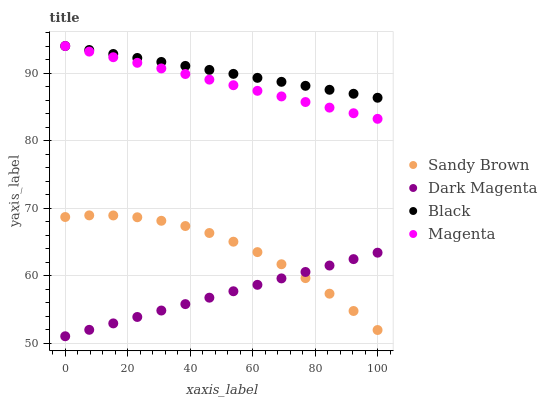Does Dark Magenta have the minimum area under the curve?
Answer yes or no. Yes. Does Black have the maximum area under the curve?
Answer yes or no. Yes. Does Magenta have the minimum area under the curve?
Answer yes or no. No. Does Magenta have the maximum area under the curve?
Answer yes or no. No. Is Dark Magenta the smoothest?
Answer yes or no. Yes. Is Sandy Brown the roughest?
Answer yes or no. Yes. Is Magenta the smoothest?
Answer yes or no. No. Is Magenta the roughest?
Answer yes or no. No. Does Dark Magenta have the lowest value?
Answer yes or no. Yes. Does Magenta have the lowest value?
Answer yes or no. No. Does Magenta have the highest value?
Answer yes or no. Yes. Does Sandy Brown have the highest value?
Answer yes or no. No. Is Sandy Brown less than Black?
Answer yes or no. Yes. Is Black greater than Dark Magenta?
Answer yes or no. Yes. Does Black intersect Magenta?
Answer yes or no. Yes. Is Black less than Magenta?
Answer yes or no. No. Is Black greater than Magenta?
Answer yes or no. No. Does Sandy Brown intersect Black?
Answer yes or no. No. 